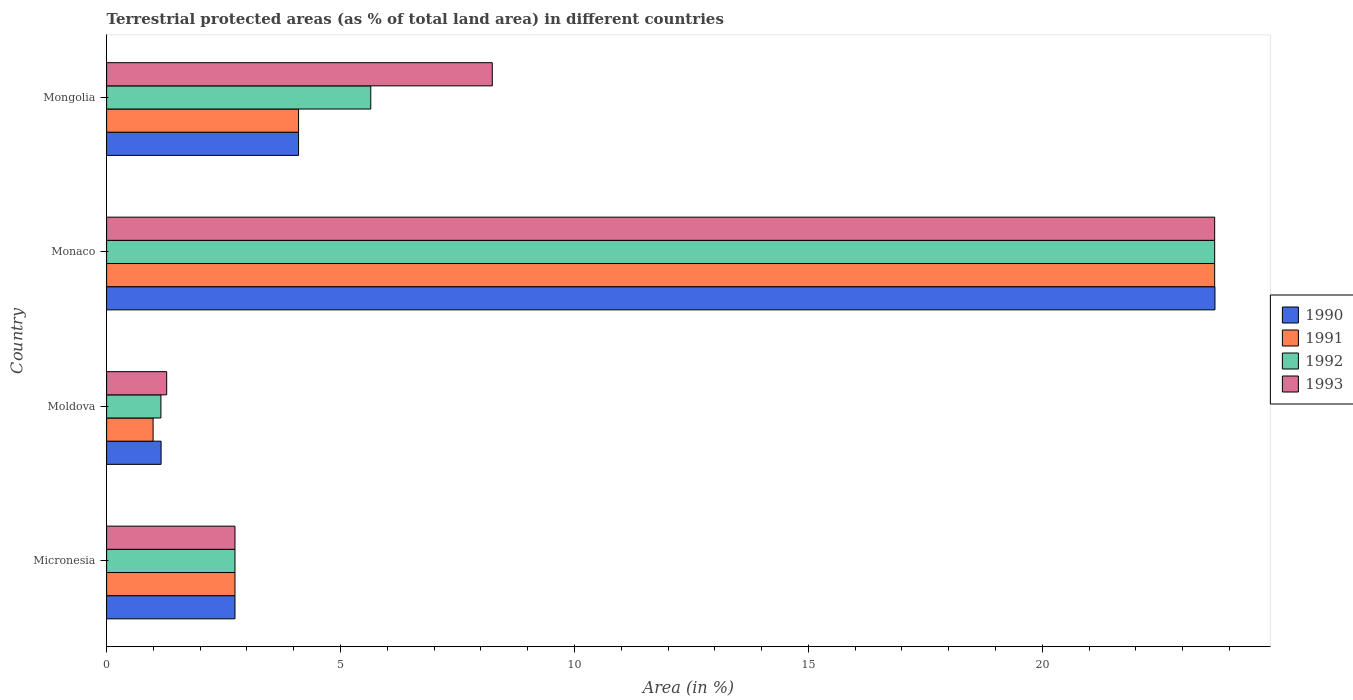How many different coloured bars are there?
Your response must be concise. 4. How many groups of bars are there?
Your response must be concise. 4. Are the number of bars per tick equal to the number of legend labels?
Your answer should be very brief. Yes. Are the number of bars on each tick of the Y-axis equal?
Your answer should be compact. Yes. How many bars are there on the 3rd tick from the bottom?
Your response must be concise. 4. What is the label of the 4th group of bars from the top?
Keep it short and to the point. Micronesia. What is the percentage of terrestrial protected land in 1990 in Monaco?
Give a very brief answer. 23.69. Across all countries, what is the maximum percentage of terrestrial protected land in 1992?
Offer a very short reply. 23.68. Across all countries, what is the minimum percentage of terrestrial protected land in 1993?
Make the answer very short. 1.28. In which country was the percentage of terrestrial protected land in 1993 maximum?
Keep it short and to the point. Monaco. In which country was the percentage of terrestrial protected land in 1991 minimum?
Offer a terse response. Moldova. What is the total percentage of terrestrial protected land in 1991 in the graph?
Offer a very short reply. 31.52. What is the difference between the percentage of terrestrial protected land in 1990 in Moldova and that in Monaco?
Keep it short and to the point. -22.53. What is the difference between the percentage of terrestrial protected land in 1990 in Mongolia and the percentage of terrestrial protected land in 1993 in Micronesia?
Your response must be concise. 1.36. What is the average percentage of terrestrial protected land in 1991 per country?
Your response must be concise. 7.88. What is the difference between the percentage of terrestrial protected land in 1990 and percentage of terrestrial protected land in 1992 in Micronesia?
Give a very brief answer. -7.308877282996562e-5. What is the ratio of the percentage of terrestrial protected land in 1993 in Moldova to that in Monaco?
Offer a terse response. 0.05. What is the difference between the highest and the second highest percentage of terrestrial protected land in 1993?
Your response must be concise. 15.44. What is the difference between the highest and the lowest percentage of terrestrial protected land in 1992?
Keep it short and to the point. 22.52. What does the 2nd bar from the bottom in Micronesia represents?
Make the answer very short. 1991. Are the values on the major ticks of X-axis written in scientific E-notation?
Keep it short and to the point. No. Does the graph contain any zero values?
Offer a terse response. No. Where does the legend appear in the graph?
Provide a short and direct response. Center right. How many legend labels are there?
Offer a very short reply. 4. What is the title of the graph?
Your answer should be very brief. Terrestrial protected areas (as % of total land area) in different countries. What is the label or title of the X-axis?
Your response must be concise. Area (in %). What is the label or title of the Y-axis?
Offer a terse response. Country. What is the Area (in %) in 1990 in Micronesia?
Your answer should be very brief. 2.74. What is the Area (in %) of 1991 in Micronesia?
Provide a succinct answer. 2.74. What is the Area (in %) in 1992 in Micronesia?
Your response must be concise. 2.74. What is the Area (in %) of 1993 in Micronesia?
Give a very brief answer. 2.74. What is the Area (in %) of 1990 in Moldova?
Ensure brevity in your answer.  1.16. What is the Area (in %) of 1991 in Moldova?
Your answer should be very brief. 0.99. What is the Area (in %) of 1992 in Moldova?
Make the answer very short. 1.16. What is the Area (in %) in 1993 in Moldova?
Your answer should be very brief. 1.28. What is the Area (in %) in 1990 in Monaco?
Offer a very short reply. 23.69. What is the Area (in %) of 1991 in Monaco?
Keep it short and to the point. 23.68. What is the Area (in %) in 1992 in Monaco?
Your answer should be very brief. 23.68. What is the Area (in %) of 1993 in Monaco?
Offer a very short reply. 23.68. What is the Area (in %) of 1990 in Mongolia?
Give a very brief answer. 4.1. What is the Area (in %) of 1991 in Mongolia?
Give a very brief answer. 4.1. What is the Area (in %) in 1992 in Mongolia?
Make the answer very short. 5.65. What is the Area (in %) of 1993 in Mongolia?
Provide a short and direct response. 8.24. Across all countries, what is the maximum Area (in %) of 1990?
Your response must be concise. 23.69. Across all countries, what is the maximum Area (in %) of 1991?
Keep it short and to the point. 23.68. Across all countries, what is the maximum Area (in %) of 1992?
Provide a succinct answer. 23.68. Across all countries, what is the maximum Area (in %) in 1993?
Offer a terse response. 23.68. Across all countries, what is the minimum Area (in %) in 1990?
Offer a terse response. 1.16. Across all countries, what is the minimum Area (in %) of 1991?
Your response must be concise. 0.99. Across all countries, what is the minimum Area (in %) of 1992?
Make the answer very short. 1.16. Across all countries, what is the minimum Area (in %) of 1993?
Your answer should be compact. 1.28. What is the total Area (in %) in 1990 in the graph?
Provide a short and direct response. 31.7. What is the total Area (in %) of 1991 in the graph?
Provide a short and direct response. 31.52. What is the total Area (in %) of 1992 in the graph?
Your answer should be very brief. 33.24. What is the total Area (in %) in 1993 in the graph?
Your response must be concise. 35.96. What is the difference between the Area (in %) of 1990 in Micronesia and that in Moldova?
Your answer should be compact. 1.58. What is the difference between the Area (in %) of 1991 in Micronesia and that in Moldova?
Your answer should be compact. 1.75. What is the difference between the Area (in %) in 1992 in Micronesia and that in Moldova?
Your answer should be compact. 1.58. What is the difference between the Area (in %) of 1993 in Micronesia and that in Moldova?
Provide a succinct answer. 1.46. What is the difference between the Area (in %) in 1990 in Micronesia and that in Monaco?
Provide a short and direct response. -20.95. What is the difference between the Area (in %) of 1991 in Micronesia and that in Monaco?
Your answer should be compact. -20.94. What is the difference between the Area (in %) in 1992 in Micronesia and that in Monaco?
Offer a very short reply. -20.94. What is the difference between the Area (in %) in 1993 in Micronesia and that in Monaco?
Provide a short and direct response. -20.94. What is the difference between the Area (in %) of 1990 in Micronesia and that in Mongolia?
Offer a very short reply. -1.36. What is the difference between the Area (in %) of 1991 in Micronesia and that in Mongolia?
Provide a short and direct response. -1.36. What is the difference between the Area (in %) in 1992 in Micronesia and that in Mongolia?
Give a very brief answer. -2.9. What is the difference between the Area (in %) of 1993 in Micronesia and that in Mongolia?
Your answer should be very brief. -5.5. What is the difference between the Area (in %) of 1990 in Moldova and that in Monaco?
Provide a short and direct response. -22.53. What is the difference between the Area (in %) in 1991 in Moldova and that in Monaco?
Offer a terse response. -22.69. What is the difference between the Area (in %) in 1992 in Moldova and that in Monaco?
Keep it short and to the point. -22.52. What is the difference between the Area (in %) in 1993 in Moldova and that in Monaco?
Offer a terse response. -22.4. What is the difference between the Area (in %) in 1990 in Moldova and that in Mongolia?
Ensure brevity in your answer.  -2.94. What is the difference between the Area (in %) in 1991 in Moldova and that in Mongolia?
Your answer should be compact. -3.11. What is the difference between the Area (in %) in 1992 in Moldova and that in Mongolia?
Your response must be concise. -4.49. What is the difference between the Area (in %) in 1993 in Moldova and that in Mongolia?
Keep it short and to the point. -6.96. What is the difference between the Area (in %) in 1990 in Monaco and that in Mongolia?
Your response must be concise. 19.59. What is the difference between the Area (in %) of 1991 in Monaco and that in Mongolia?
Offer a terse response. 19.58. What is the difference between the Area (in %) in 1992 in Monaco and that in Mongolia?
Provide a succinct answer. 18.04. What is the difference between the Area (in %) of 1993 in Monaco and that in Mongolia?
Your response must be concise. 15.44. What is the difference between the Area (in %) of 1990 in Micronesia and the Area (in %) of 1991 in Moldova?
Provide a short and direct response. 1.75. What is the difference between the Area (in %) in 1990 in Micronesia and the Area (in %) in 1992 in Moldova?
Provide a short and direct response. 1.58. What is the difference between the Area (in %) of 1990 in Micronesia and the Area (in %) of 1993 in Moldova?
Provide a short and direct response. 1.46. What is the difference between the Area (in %) in 1991 in Micronesia and the Area (in %) in 1992 in Moldova?
Your response must be concise. 1.58. What is the difference between the Area (in %) in 1991 in Micronesia and the Area (in %) in 1993 in Moldova?
Offer a very short reply. 1.46. What is the difference between the Area (in %) in 1992 in Micronesia and the Area (in %) in 1993 in Moldova?
Your answer should be compact. 1.46. What is the difference between the Area (in %) of 1990 in Micronesia and the Area (in %) of 1991 in Monaco?
Keep it short and to the point. -20.94. What is the difference between the Area (in %) of 1990 in Micronesia and the Area (in %) of 1992 in Monaco?
Offer a very short reply. -20.94. What is the difference between the Area (in %) of 1990 in Micronesia and the Area (in %) of 1993 in Monaco?
Offer a very short reply. -20.94. What is the difference between the Area (in %) in 1991 in Micronesia and the Area (in %) in 1992 in Monaco?
Your answer should be very brief. -20.94. What is the difference between the Area (in %) of 1991 in Micronesia and the Area (in %) of 1993 in Monaco?
Provide a short and direct response. -20.94. What is the difference between the Area (in %) in 1992 in Micronesia and the Area (in %) in 1993 in Monaco?
Ensure brevity in your answer.  -20.94. What is the difference between the Area (in %) in 1990 in Micronesia and the Area (in %) in 1991 in Mongolia?
Give a very brief answer. -1.36. What is the difference between the Area (in %) in 1990 in Micronesia and the Area (in %) in 1992 in Mongolia?
Your answer should be very brief. -2.9. What is the difference between the Area (in %) in 1990 in Micronesia and the Area (in %) in 1993 in Mongolia?
Your response must be concise. -5.5. What is the difference between the Area (in %) in 1991 in Micronesia and the Area (in %) in 1992 in Mongolia?
Your answer should be compact. -2.9. What is the difference between the Area (in %) in 1991 in Micronesia and the Area (in %) in 1993 in Mongolia?
Keep it short and to the point. -5.5. What is the difference between the Area (in %) in 1992 in Micronesia and the Area (in %) in 1993 in Mongolia?
Offer a terse response. -5.5. What is the difference between the Area (in %) in 1990 in Moldova and the Area (in %) in 1991 in Monaco?
Provide a short and direct response. -22.52. What is the difference between the Area (in %) of 1990 in Moldova and the Area (in %) of 1992 in Monaco?
Give a very brief answer. -22.52. What is the difference between the Area (in %) in 1990 in Moldova and the Area (in %) in 1993 in Monaco?
Give a very brief answer. -22.52. What is the difference between the Area (in %) in 1991 in Moldova and the Area (in %) in 1992 in Monaco?
Offer a terse response. -22.69. What is the difference between the Area (in %) in 1991 in Moldova and the Area (in %) in 1993 in Monaco?
Your answer should be very brief. -22.69. What is the difference between the Area (in %) of 1992 in Moldova and the Area (in %) of 1993 in Monaco?
Your answer should be compact. -22.52. What is the difference between the Area (in %) of 1990 in Moldova and the Area (in %) of 1991 in Mongolia?
Provide a short and direct response. -2.94. What is the difference between the Area (in %) of 1990 in Moldova and the Area (in %) of 1992 in Mongolia?
Keep it short and to the point. -4.48. What is the difference between the Area (in %) in 1990 in Moldova and the Area (in %) in 1993 in Mongolia?
Offer a terse response. -7.08. What is the difference between the Area (in %) of 1991 in Moldova and the Area (in %) of 1992 in Mongolia?
Keep it short and to the point. -4.65. What is the difference between the Area (in %) in 1991 in Moldova and the Area (in %) in 1993 in Mongolia?
Provide a short and direct response. -7.25. What is the difference between the Area (in %) in 1992 in Moldova and the Area (in %) in 1993 in Mongolia?
Give a very brief answer. -7.08. What is the difference between the Area (in %) in 1990 in Monaco and the Area (in %) in 1991 in Mongolia?
Keep it short and to the point. 19.59. What is the difference between the Area (in %) of 1990 in Monaco and the Area (in %) of 1992 in Mongolia?
Provide a succinct answer. 18.04. What is the difference between the Area (in %) of 1990 in Monaco and the Area (in %) of 1993 in Mongolia?
Keep it short and to the point. 15.45. What is the difference between the Area (in %) in 1991 in Monaco and the Area (in %) in 1992 in Mongolia?
Give a very brief answer. 18.04. What is the difference between the Area (in %) of 1991 in Monaco and the Area (in %) of 1993 in Mongolia?
Give a very brief answer. 15.44. What is the difference between the Area (in %) in 1992 in Monaco and the Area (in %) in 1993 in Mongolia?
Make the answer very short. 15.44. What is the average Area (in %) in 1990 per country?
Provide a short and direct response. 7.93. What is the average Area (in %) of 1991 per country?
Offer a very short reply. 7.88. What is the average Area (in %) in 1992 per country?
Provide a short and direct response. 8.31. What is the average Area (in %) in 1993 per country?
Keep it short and to the point. 8.99. What is the difference between the Area (in %) in 1990 and Area (in %) in 1991 in Micronesia?
Provide a short and direct response. -0. What is the difference between the Area (in %) of 1990 and Area (in %) of 1992 in Micronesia?
Your response must be concise. -0. What is the difference between the Area (in %) in 1990 and Area (in %) in 1993 in Micronesia?
Offer a terse response. -0. What is the difference between the Area (in %) of 1991 and Area (in %) of 1993 in Micronesia?
Your answer should be compact. 0. What is the difference between the Area (in %) in 1992 and Area (in %) in 1993 in Micronesia?
Your response must be concise. 0. What is the difference between the Area (in %) of 1990 and Area (in %) of 1991 in Moldova?
Make the answer very short. 0.17. What is the difference between the Area (in %) of 1990 and Area (in %) of 1992 in Moldova?
Your response must be concise. 0. What is the difference between the Area (in %) in 1990 and Area (in %) in 1993 in Moldova?
Your answer should be compact. -0.12. What is the difference between the Area (in %) of 1991 and Area (in %) of 1992 in Moldova?
Provide a short and direct response. -0.17. What is the difference between the Area (in %) in 1991 and Area (in %) in 1993 in Moldova?
Provide a succinct answer. -0.29. What is the difference between the Area (in %) of 1992 and Area (in %) of 1993 in Moldova?
Provide a short and direct response. -0.12. What is the difference between the Area (in %) in 1990 and Area (in %) in 1991 in Monaco?
Provide a short and direct response. 0.01. What is the difference between the Area (in %) in 1990 and Area (in %) in 1992 in Monaco?
Give a very brief answer. 0.01. What is the difference between the Area (in %) in 1990 and Area (in %) in 1993 in Monaco?
Offer a very short reply. 0.01. What is the difference between the Area (in %) of 1991 and Area (in %) of 1992 in Monaco?
Give a very brief answer. 0. What is the difference between the Area (in %) of 1991 and Area (in %) of 1993 in Monaco?
Offer a very short reply. 0. What is the difference between the Area (in %) of 1990 and Area (in %) of 1991 in Mongolia?
Provide a short and direct response. -0. What is the difference between the Area (in %) in 1990 and Area (in %) in 1992 in Mongolia?
Your response must be concise. -1.54. What is the difference between the Area (in %) of 1990 and Area (in %) of 1993 in Mongolia?
Give a very brief answer. -4.14. What is the difference between the Area (in %) in 1991 and Area (in %) in 1992 in Mongolia?
Ensure brevity in your answer.  -1.54. What is the difference between the Area (in %) of 1991 and Area (in %) of 1993 in Mongolia?
Offer a terse response. -4.14. What is the difference between the Area (in %) of 1992 and Area (in %) of 1993 in Mongolia?
Offer a terse response. -2.6. What is the ratio of the Area (in %) in 1990 in Micronesia to that in Moldova?
Ensure brevity in your answer.  2.36. What is the ratio of the Area (in %) in 1991 in Micronesia to that in Moldova?
Your response must be concise. 2.76. What is the ratio of the Area (in %) of 1992 in Micronesia to that in Moldova?
Ensure brevity in your answer.  2.36. What is the ratio of the Area (in %) of 1993 in Micronesia to that in Moldova?
Keep it short and to the point. 2.14. What is the ratio of the Area (in %) in 1990 in Micronesia to that in Monaco?
Make the answer very short. 0.12. What is the ratio of the Area (in %) in 1991 in Micronesia to that in Monaco?
Offer a very short reply. 0.12. What is the ratio of the Area (in %) in 1992 in Micronesia to that in Monaco?
Offer a very short reply. 0.12. What is the ratio of the Area (in %) in 1993 in Micronesia to that in Monaco?
Give a very brief answer. 0.12. What is the ratio of the Area (in %) in 1990 in Micronesia to that in Mongolia?
Offer a very short reply. 0.67. What is the ratio of the Area (in %) of 1991 in Micronesia to that in Mongolia?
Ensure brevity in your answer.  0.67. What is the ratio of the Area (in %) in 1992 in Micronesia to that in Mongolia?
Ensure brevity in your answer.  0.49. What is the ratio of the Area (in %) of 1993 in Micronesia to that in Mongolia?
Your answer should be very brief. 0.33. What is the ratio of the Area (in %) in 1990 in Moldova to that in Monaco?
Make the answer very short. 0.05. What is the ratio of the Area (in %) in 1991 in Moldova to that in Monaco?
Offer a very short reply. 0.04. What is the ratio of the Area (in %) of 1992 in Moldova to that in Monaco?
Provide a short and direct response. 0.05. What is the ratio of the Area (in %) in 1993 in Moldova to that in Monaco?
Provide a short and direct response. 0.05. What is the ratio of the Area (in %) in 1990 in Moldova to that in Mongolia?
Provide a short and direct response. 0.28. What is the ratio of the Area (in %) in 1991 in Moldova to that in Mongolia?
Ensure brevity in your answer.  0.24. What is the ratio of the Area (in %) of 1992 in Moldova to that in Mongolia?
Keep it short and to the point. 0.21. What is the ratio of the Area (in %) in 1993 in Moldova to that in Mongolia?
Your answer should be compact. 0.16. What is the ratio of the Area (in %) of 1990 in Monaco to that in Mongolia?
Offer a very short reply. 5.77. What is the ratio of the Area (in %) in 1991 in Monaco to that in Mongolia?
Your response must be concise. 5.77. What is the ratio of the Area (in %) of 1992 in Monaco to that in Mongolia?
Make the answer very short. 4.19. What is the ratio of the Area (in %) in 1993 in Monaco to that in Mongolia?
Give a very brief answer. 2.87. What is the difference between the highest and the second highest Area (in %) in 1990?
Ensure brevity in your answer.  19.59. What is the difference between the highest and the second highest Area (in %) in 1991?
Make the answer very short. 19.58. What is the difference between the highest and the second highest Area (in %) in 1992?
Keep it short and to the point. 18.04. What is the difference between the highest and the second highest Area (in %) of 1993?
Offer a terse response. 15.44. What is the difference between the highest and the lowest Area (in %) in 1990?
Offer a terse response. 22.53. What is the difference between the highest and the lowest Area (in %) of 1991?
Provide a short and direct response. 22.69. What is the difference between the highest and the lowest Area (in %) of 1992?
Provide a succinct answer. 22.52. What is the difference between the highest and the lowest Area (in %) in 1993?
Offer a terse response. 22.4. 